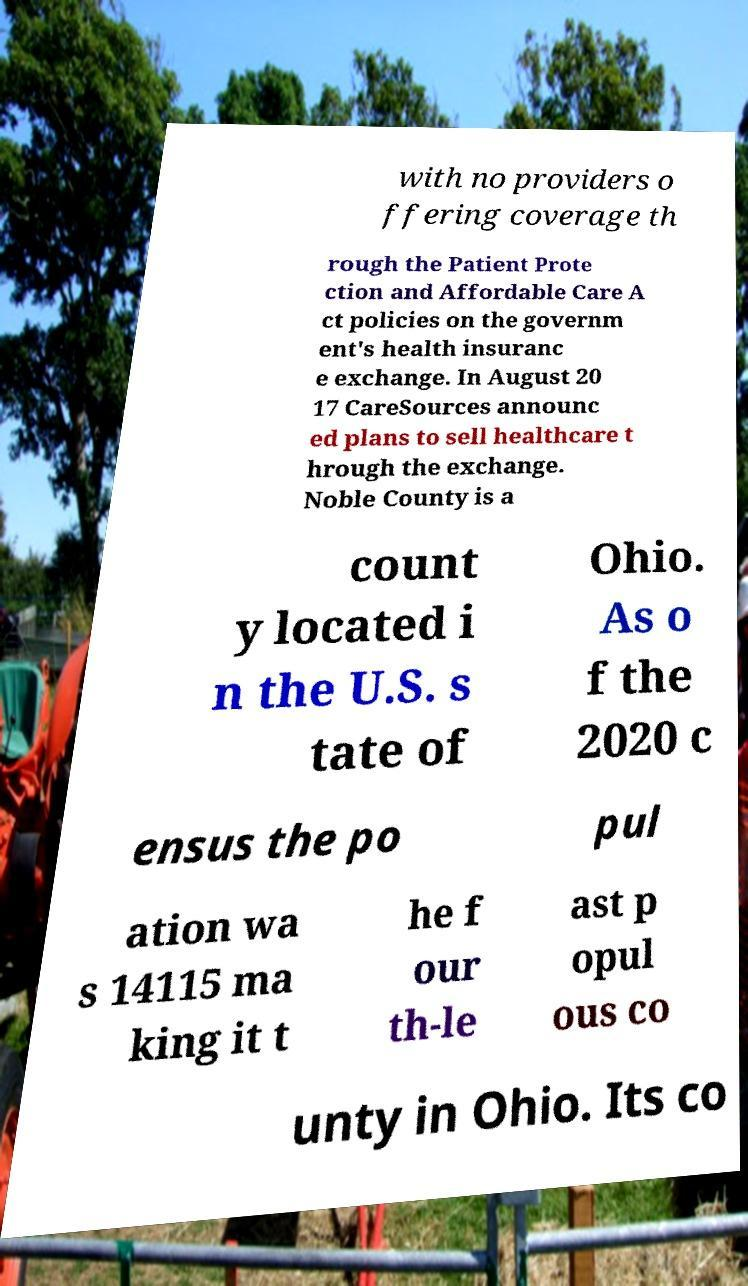Please read and relay the text visible in this image. What does it say? with no providers o ffering coverage th rough the Patient Prote ction and Affordable Care A ct policies on the governm ent's health insuranc e exchange. In August 20 17 CareSources announc ed plans to sell healthcare t hrough the exchange. Noble County is a count y located i n the U.S. s tate of Ohio. As o f the 2020 c ensus the po pul ation wa s 14115 ma king it t he f our th-le ast p opul ous co unty in Ohio. Its co 